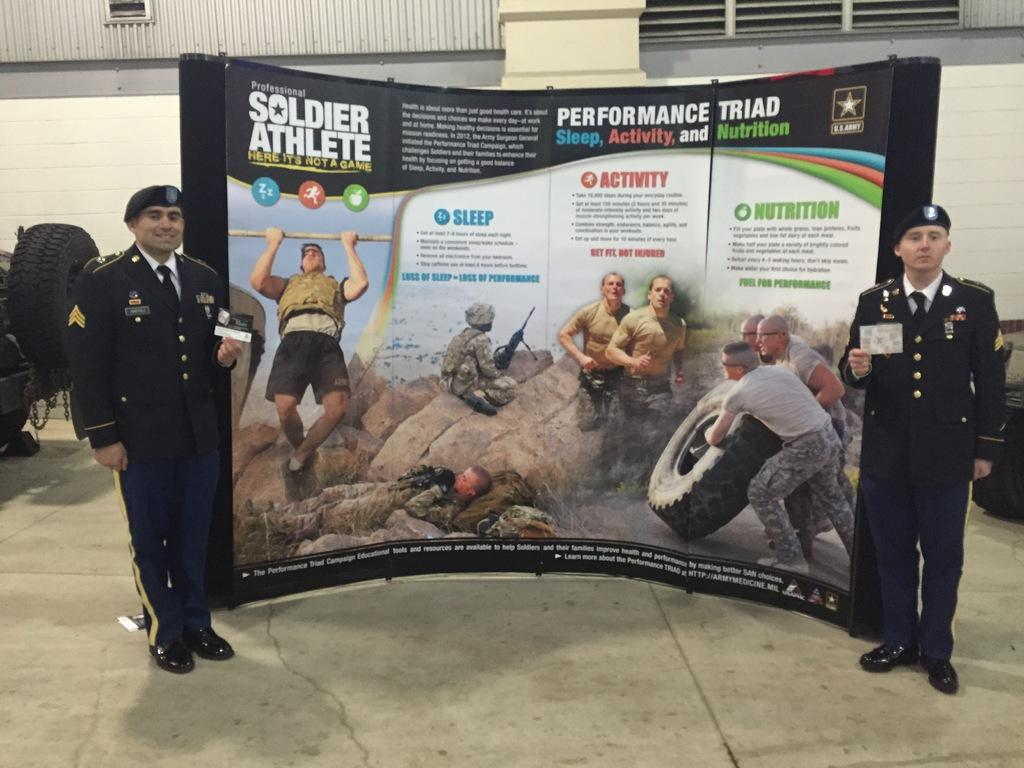How many people are in the image? Two persons are standing in the middle of the image. What are the persons holding in the image? The persons are holding a paper. What can be seen behind the persons? There is a banner behind the persons, and a wall behind the banner. What else is visible in the image? There are wheels visible in the image. How many cherries are on the scale in the image? There is no scale or cherries present in the image. What type of protest is taking place in the image? There is no protest or indication of any protest-related activity in the image. 